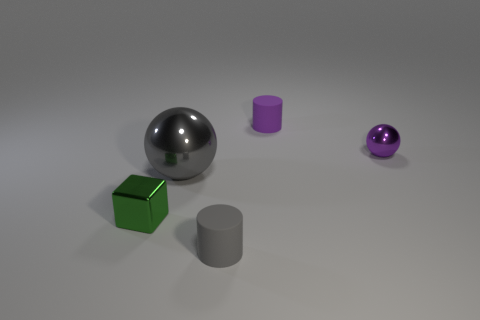Add 5 matte cylinders. How many objects exist? 10 Subtract all cylinders. How many objects are left? 3 Add 1 large blue matte cylinders. How many large blue matte cylinders exist? 1 Subtract 0 yellow blocks. How many objects are left? 5 Subtract all big cubes. Subtract all small gray cylinders. How many objects are left? 4 Add 5 small matte objects. How many small matte objects are left? 7 